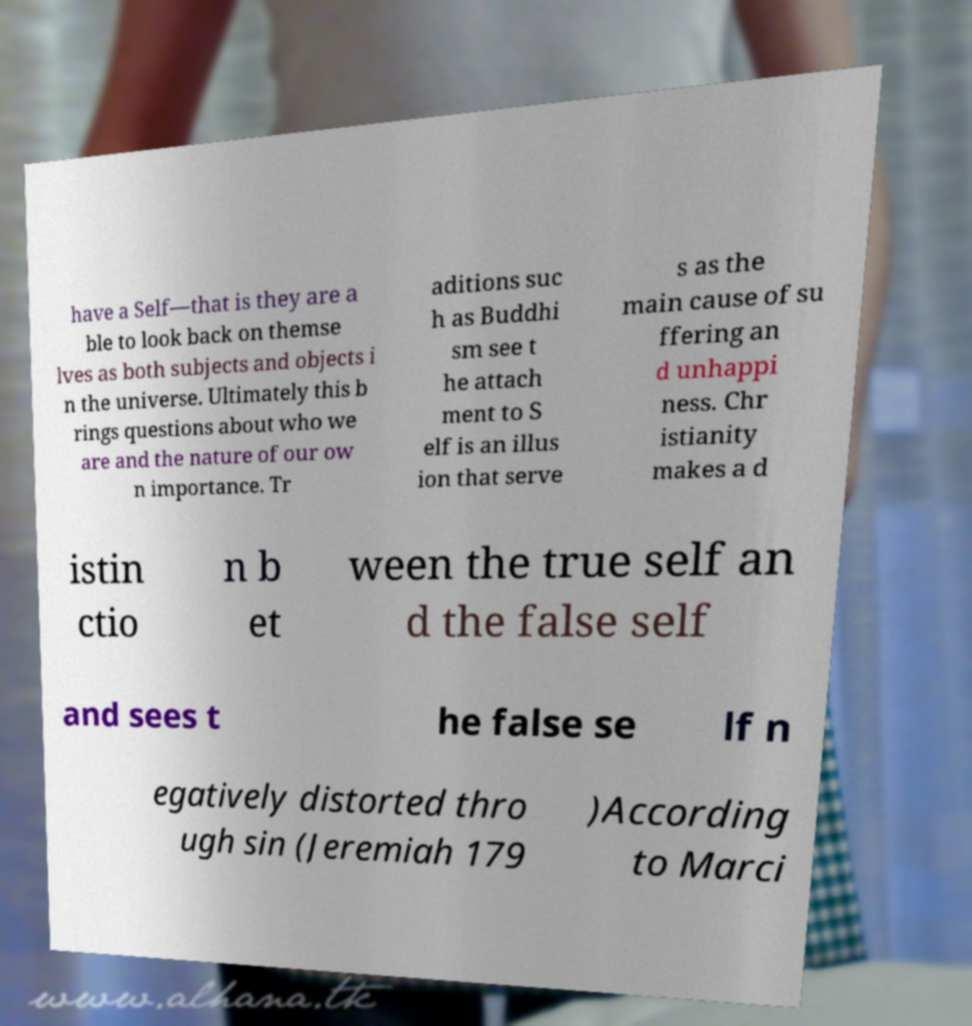Please read and relay the text visible in this image. What does it say? have a Self—that is they are a ble to look back on themse lves as both subjects and objects i n the universe. Ultimately this b rings questions about who we are and the nature of our ow n importance. Tr aditions suc h as Buddhi sm see t he attach ment to S elf is an illus ion that serve s as the main cause of su ffering an d unhappi ness. Chr istianity makes a d istin ctio n b et ween the true self an d the false self and sees t he false se lf n egatively distorted thro ugh sin (Jeremiah 179 )According to Marci 